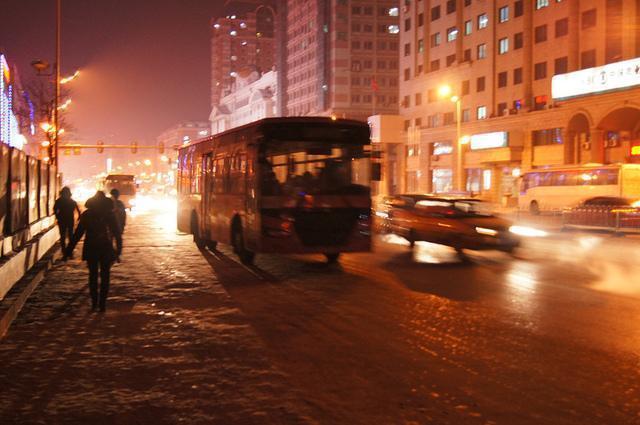What hazard appears to be occurring on the road?
Indicate the correct choice and explain in the format: 'Answer: answer
Rationale: rationale.'
Options: Too hot, too cold, water, slippery. Answer: slippery.
Rationale: The road is wet. 